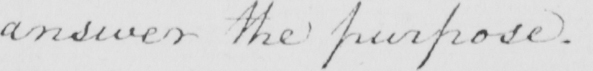What does this handwritten line say? answer the purpose . 